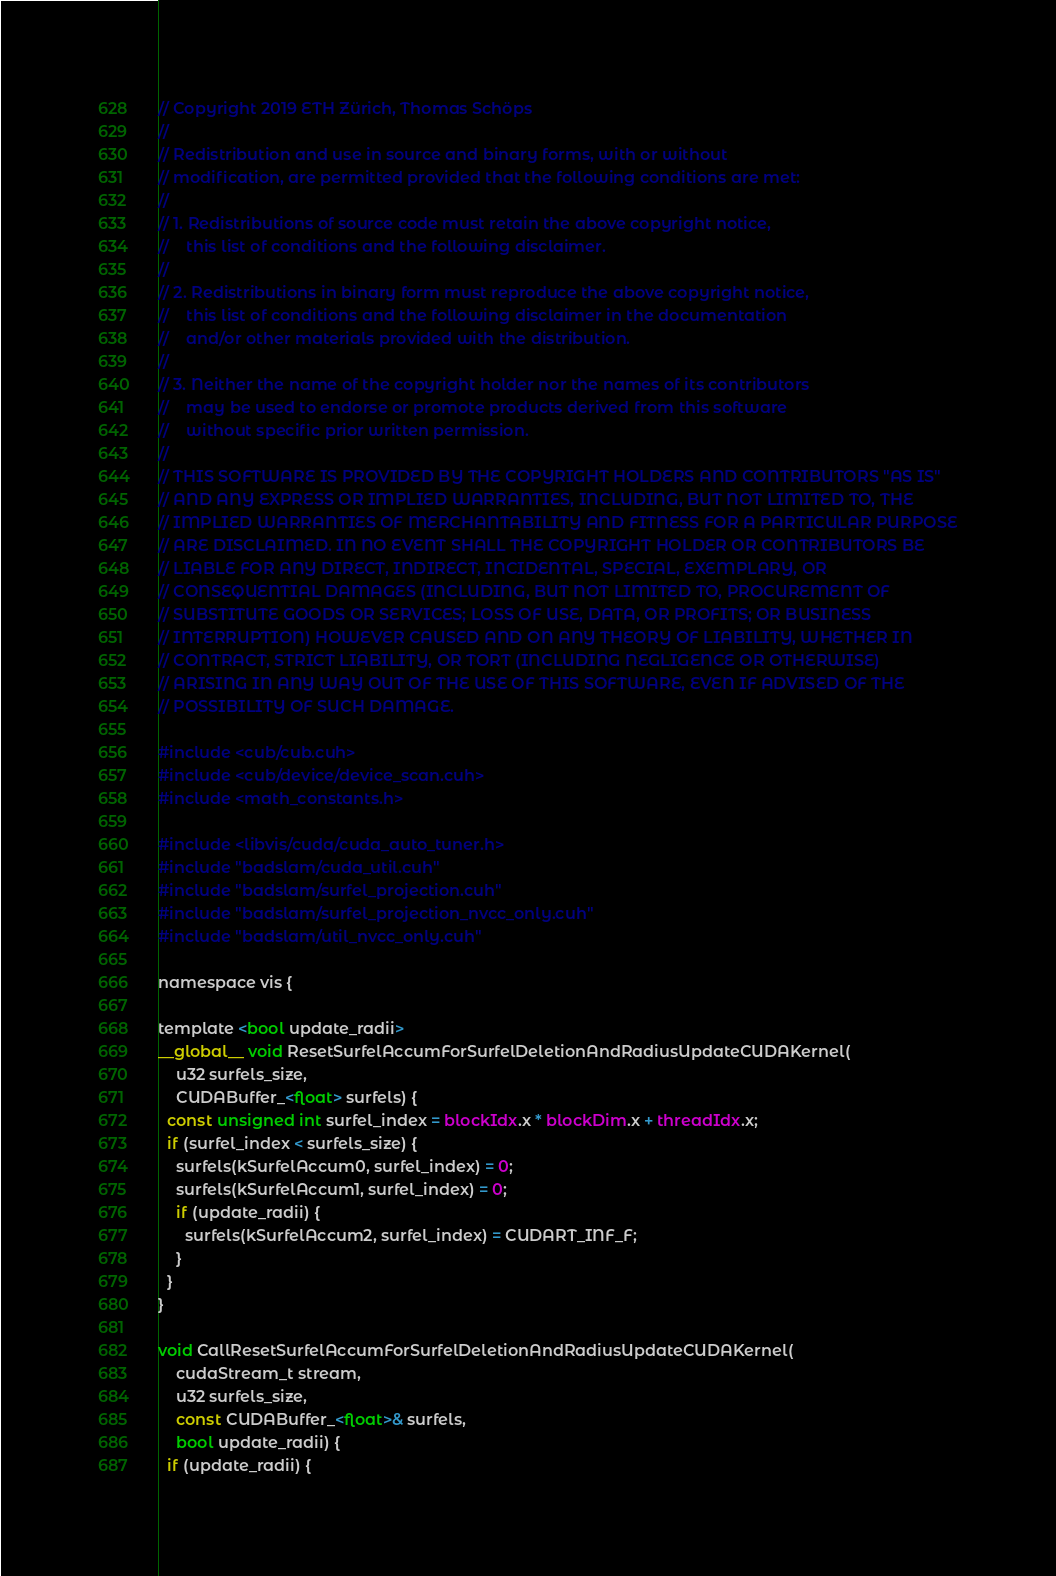Convert code to text. <code><loc_0><loc_0><loc_500><loc_500><_Cuda_>// Copyright 2019 ETH Zürich, Thomas Schöps
//
// Redistribution and use in source and binary forms, with or without
// modification, are permitted provided that the following conditions are met:
//
// 1. Redistributions of source code must retain the above copyright notice,
//    this list of conditions and the following disclaimer.
//
// 2. Redistributions in binary form must reproduce the above copyright notice,
//    this list of conditions and the following disclaimer in the documentation
//    and/or other materials provided with the distribution.
//
// 3. Neither the name of the copyright holder nor the names of its contributors
//    may be used to endorse or promote products derived from this software
//    without specific prior written permission.
//
// THIS SOFTWARE IS PROVIDED BY THE COPYRIGHT HOLDERS AND CONTRIBUTORS "AS IS"
// AND ANY EXPRESS OR IMPLIED WARRANTIES, INCLUDING, BUT NOT LIMITED TO, THE
// IMPLIED WARRANTIES OF MERCHANTABILITY AND FITNESS FOR A PARTICULAR PURPOSE
// ARE DISCLAIMED. IN NO EVENT SHALL THE COPYRIGHT HOLDER OR CONTRIBUTORS BE
// LIABLE FOR ANY DIRECT, INDIRECT, INCIDENTAL, SPECIAL, EXEMPLARY, OR
// CONSEQUENTIAL DAMAGES (INCLUDING, BUT NOT LIMITED TO, PROCUREMENT OF
// SUBSTITUTE GOODS OR SERVICES; LOSS OF USE, DATA, OR PROFITS; OR BUSINESS
// INTERRUPTION) HOWEVER CAUSED AND ON ANY THEORY OF LIABILITY, WHETHER IN
// CONTRACT, STRICT LIABILITY, OR TORT (INCLUDING NEGLIGENCE OR OTHERWISE)
// ARISING IN ANY WAY OUT OF THE USE OF THIS SOFTWARE, EVEN IF ADVISED OF THE
// POSSIBILITY OF SUCH DAMAGE.

#include <cub/cub.cuh>
#include <cub/device/device_scan.cuh>
#include <math_constants.h>

#include <libvis/cuda/cuda_auto_tuner.h>
#include "badslam/cuda_util.cuh"
#include "badslam/surfel_projection.cuh"
#include "badslam/surfel_projection_nvcc_only.cuh"
#include "badslam/util_nvcc_only.cuh"

namespace vis {

template <bool update_radii>
__global__ void ResetSurfelAccumForSurfelDeletionAndRadiusUpdateCUDAKernel(
    u32 surfels_size,
    CUDABuffer_<float> surfels) {
  const unsigned int surfel_index = blockIdx.x * blockDim.x + threadIdx.x;
  if (surfel_index < surfels_size) {
    surfels(kSurfelAccum0, surfel_index) = 0;
    surfels(kSurfelAccum1, surfel_index) = 0;
    if (update_radii) {
      surfels(kSurfelAccum2, surfel_index) = CUDART_INF_F;
    }
  }
}

void CallResetSurfelAccumForSurfelDeletionAndRadiusUpdateCUDAKernel(
    cudaStream_t stream,
    u32 surfels_size,
    const CUDABuffer_<float>& surfels,
    bool update_radii) {
  if (update_radii) {</code> 